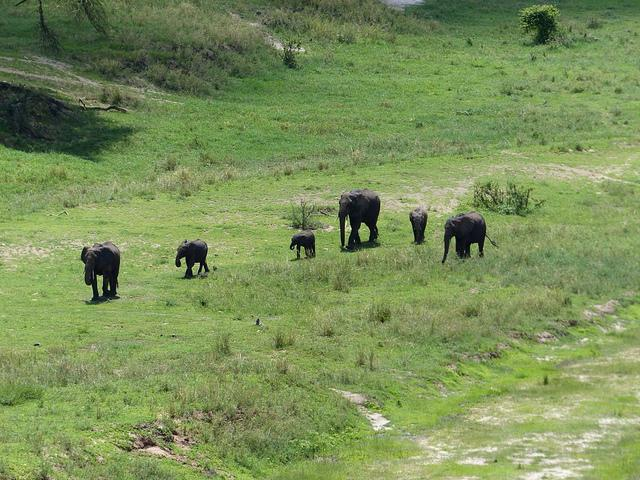What is the littlest elephant called? calf 